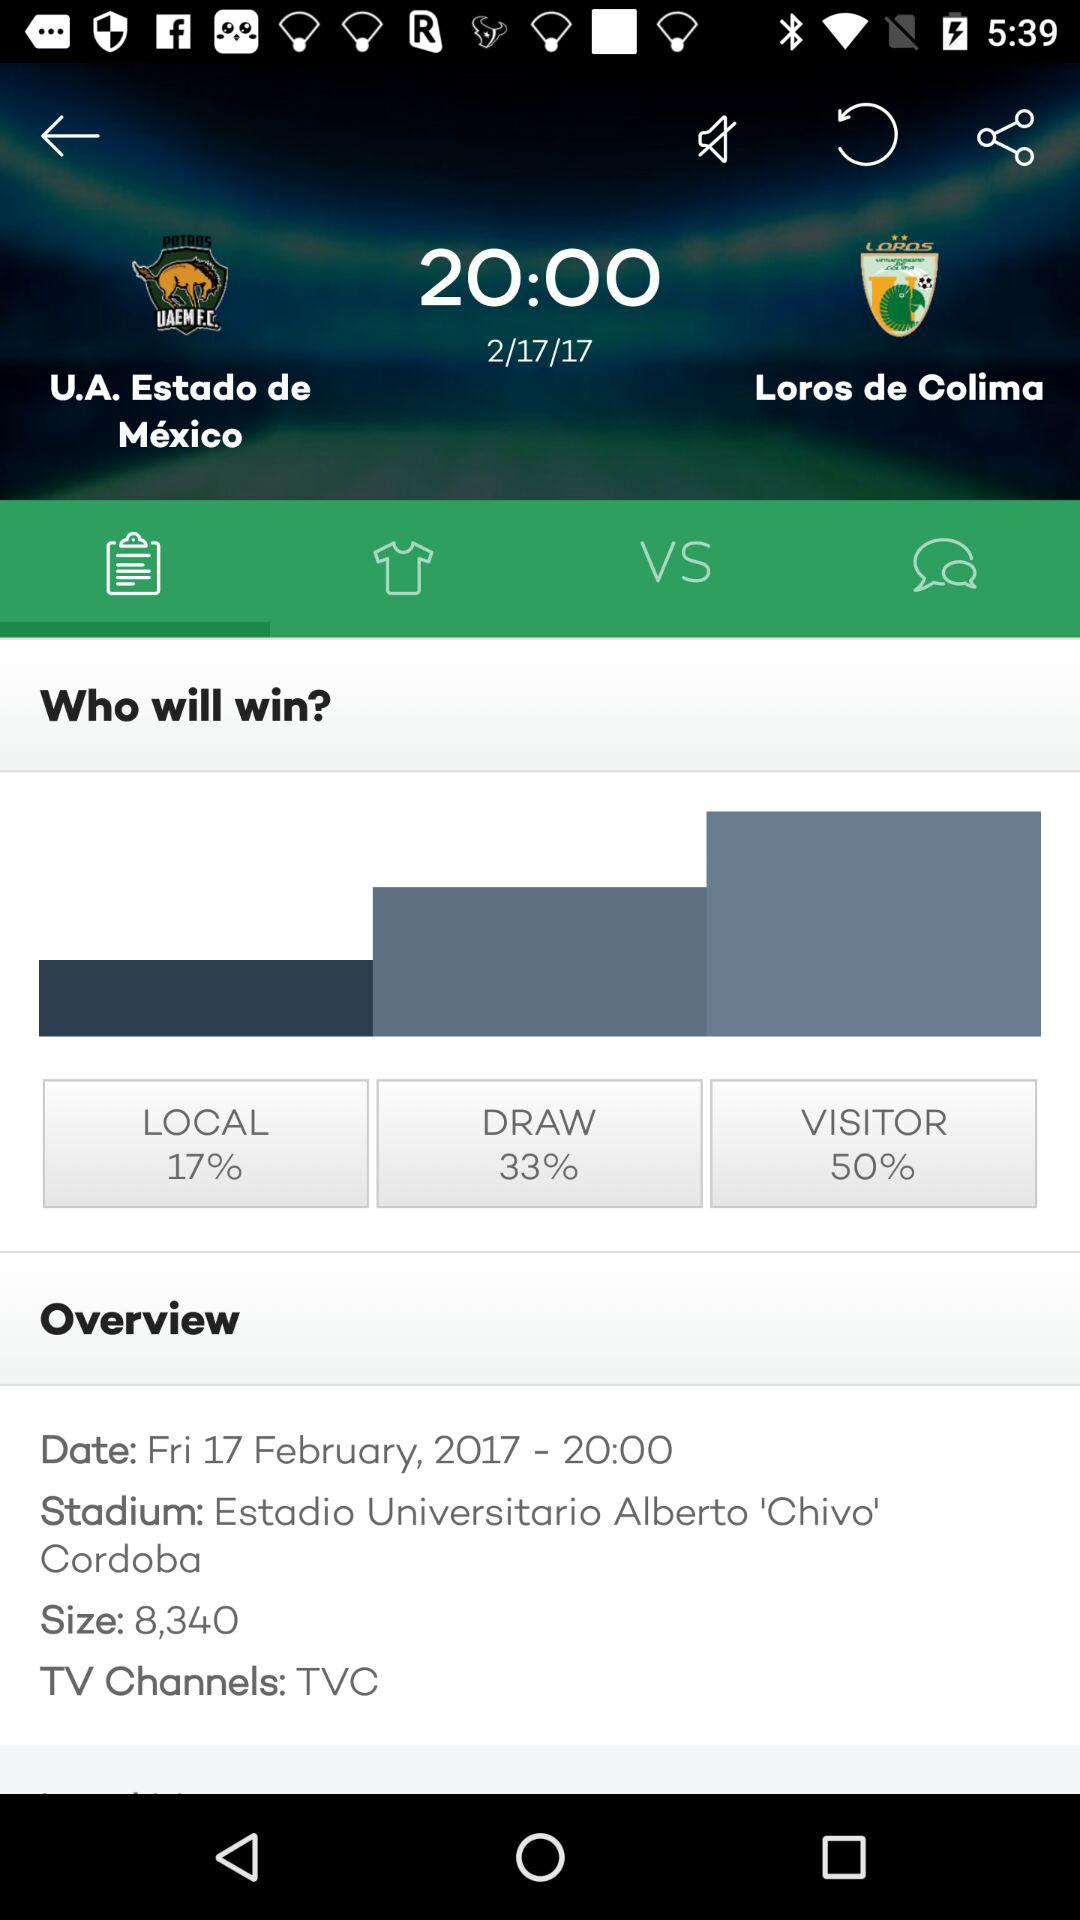What are the 2 teams? The two teams are U.A Estado de Mexico and Loros de Colima. 